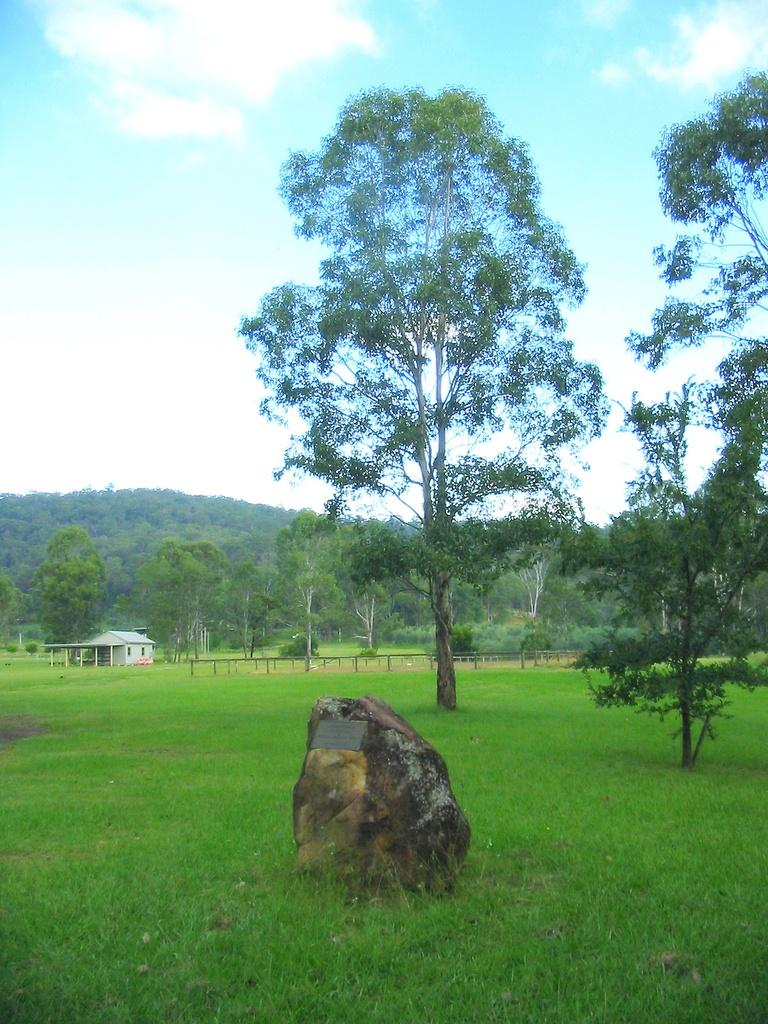What is the main object in the image? There is a rock in the image. What type of vegetation is present at the bottom of the image? There is green grass at the bottom of the image. What can be seen in the background of the image? There are many trees and plants in the background of the image. What type of structure is visible to the left of the image? There is a small house to the left of the image. What type of noise is coming from the rock in the image? There is no noise coming from the rock in the image. What type of fuel is required to power the trees in the image? Trees do not require fuel to grow or exist, so this question is not applicable to the image. 